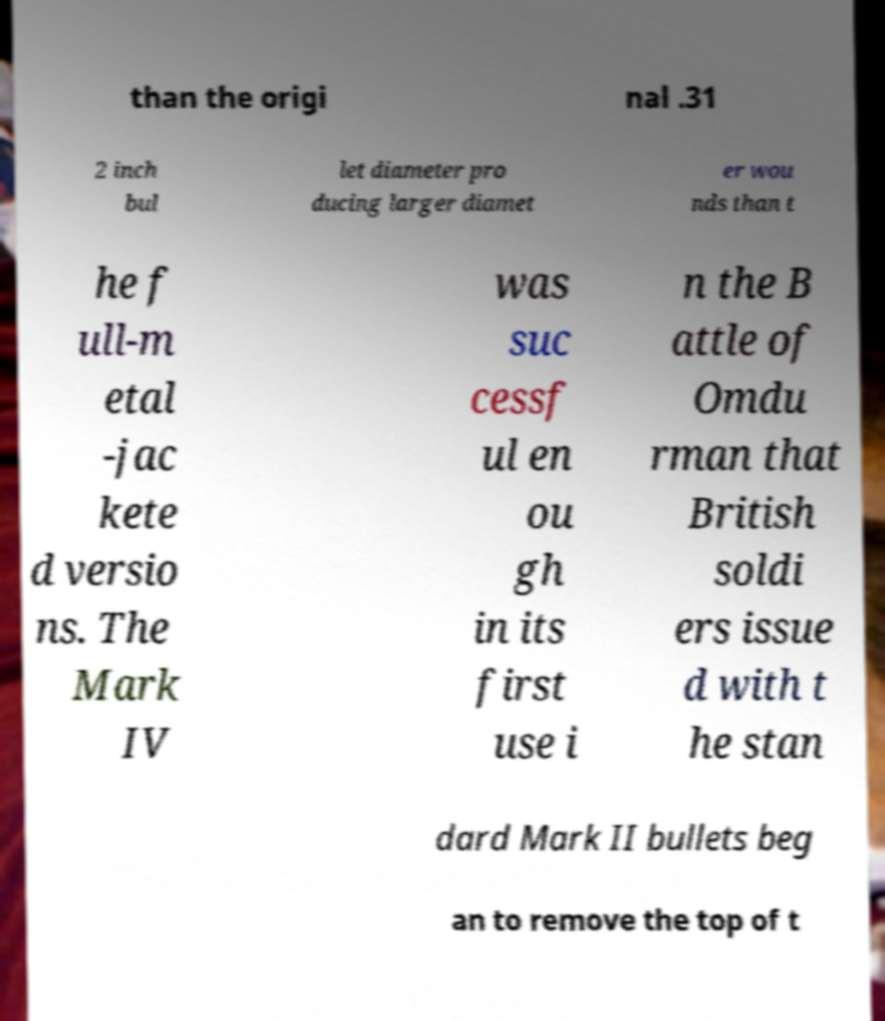There's text embedded in this image that I need extracted. Can you transcribe it verbatim? than the origi nal .31 2 inch bul let diameter pro ducing larger diamet er wou nds than t he f ull-m etal -jac kete d versio ns. The Mark IV was suc cessf ul en ou gh in its first use i n the B attle of Omdu rman that British soldi ers issue d with t he stan dard Mark II bullets beg an to remove the top of t 